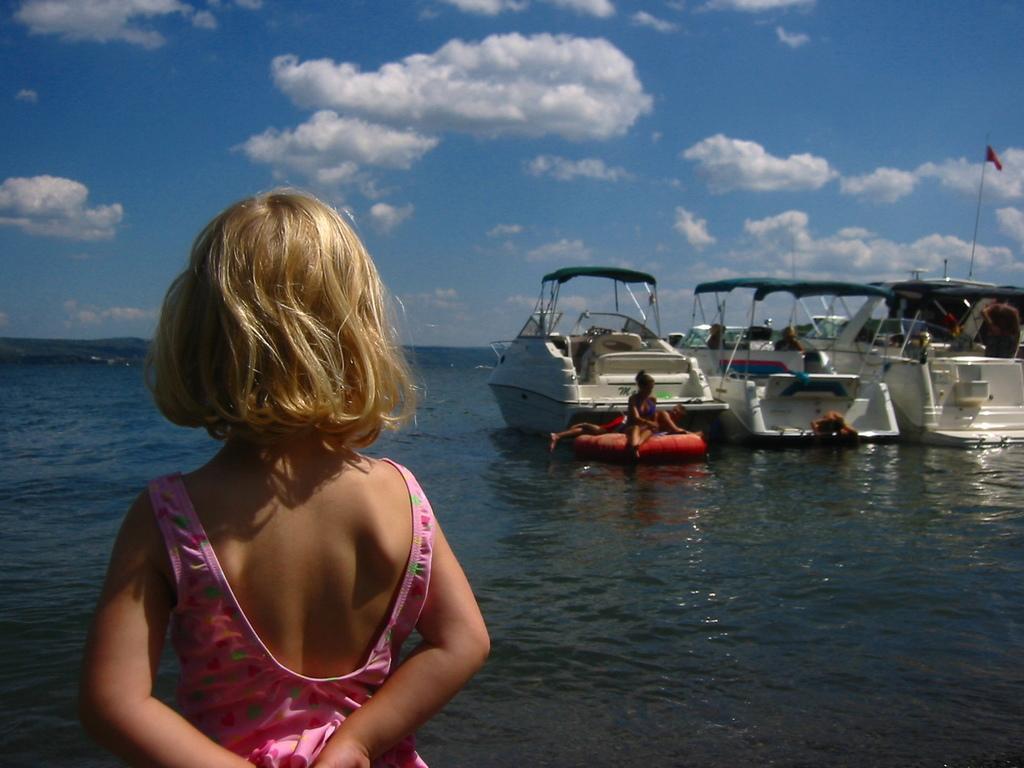Please provide a concise description of this image. This is the picture of a sea. In this image there is girl standing. At the back there are boats on the water and there are group of people on the boat. At the top there is sky and there are clouds. At the bottom there is water. 